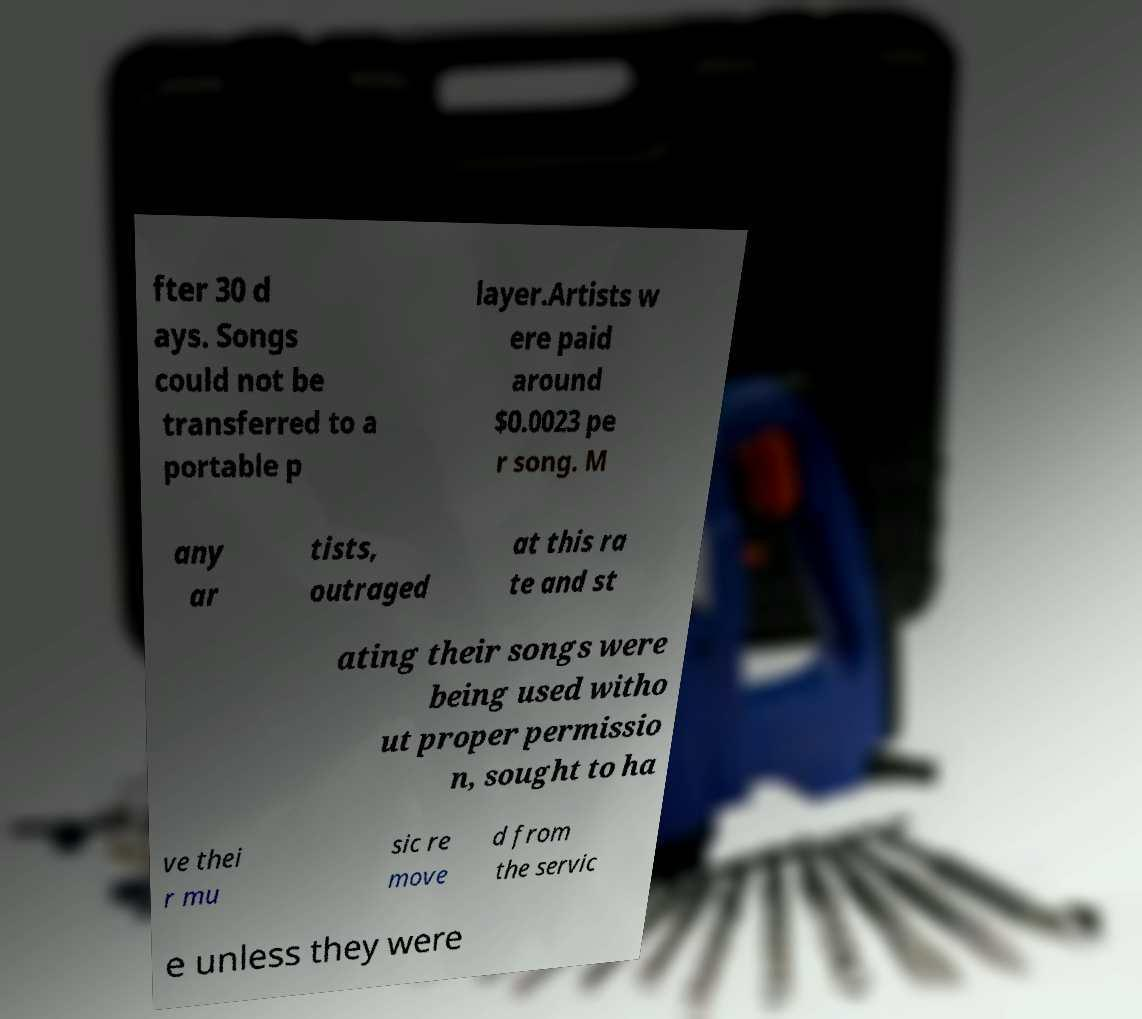There's text embedded in this image that I need extracted. Can you transcribe it verbatim? fter 30 d ays. Songs could not be transferred to a portable p layer.Artists w ere paid around $0.0023 pe r song. M any ar tists, outraged at this ra te and st ating their songs were being used witho ut proper permissio n, sought to ha ve thei r mu sic re move d from the servic e unless they were 